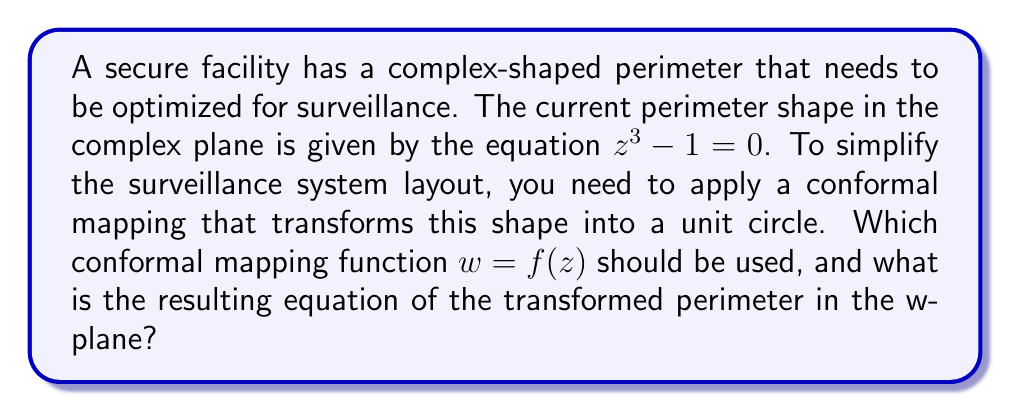Could you help me with this problem? To solve this problem, we'll follow these steps:

1) First, let's identify the shape described by the equation $z^3 - 1 = 0$. This is the equation of a deltoid, which is a three-cusped hypocycloid.

2) To transform this shape into a unit circle, we need a conformal mapping that will "unwrap" the deltoid. The appropriate mapping for this is:

   $w = f(z) = \sqrt[3]{z}$

3) Let's apply this mapping to the original equation:

   $z^3 - 1 = 0$
   $z^3 = 1$

4) Substituting $z = w^3$ (since $w = \sqrt[3]{z}$):

   $(w^3)^3 = 1$
   $w^9 = 1$

5) This equation $w^9 = 1$ represents 9 points equally spaced around the unit circle in the w-plane. To see this, we can write it in polar form:

   $w = e^{2\pi i k/9}$, where $k = 0, 1, 2, ..., 8$

6) The general equation of a unit circle in the complex plane is:

   $|w| = 1$

Therefore, the conformal mapping $w = \sqrt[3]{z}$ transforms the original deltoid shape into a unit circle in the w-plane.

[asy]
import graph;
size(200);
real f(real x) {return sqrt(abs(x));}
path g=polargraph(f,0,2pi);
draw(g,blue+linewidth(1));
draw(unitcircle,red+linewidth(1));
label("Original shape",(-1.5,0),W);
label("Transformed shape",(1.5,0),E);
[/asy]
Answer: The conformal mapping function is $w = f(z) = \sqrt[3]{z}$, and the resulting equation of the transformed perimeter in the w-plane is $|w| = 1$. 